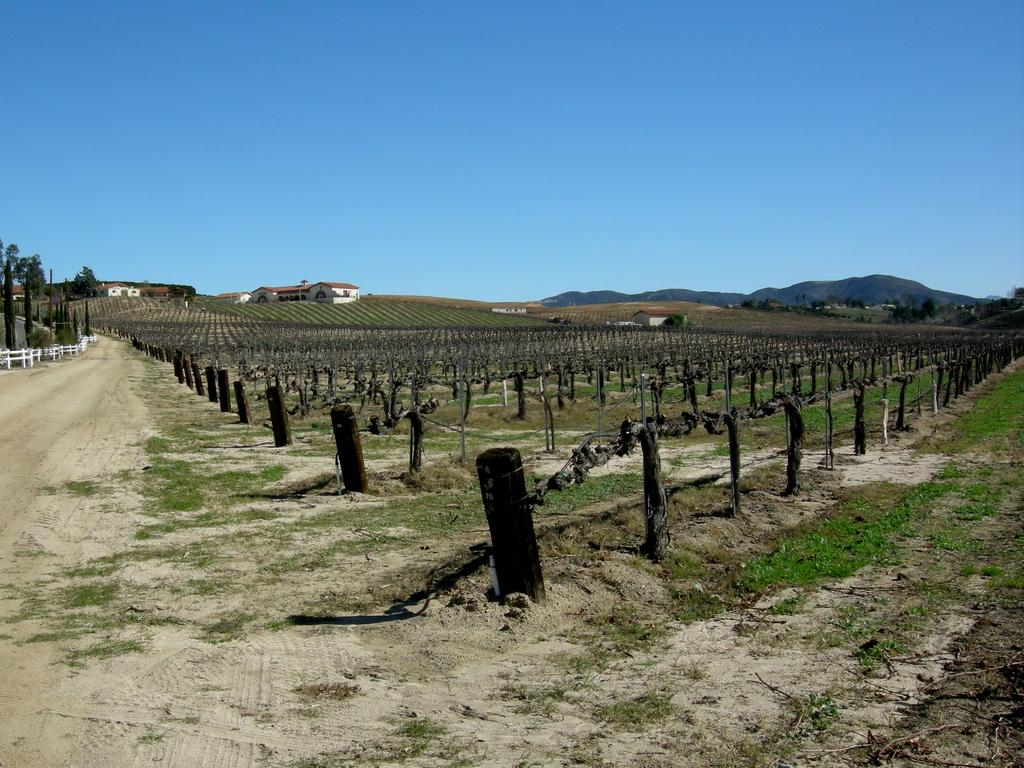What type of landscape is depicted in the image? There is a field in the image. What can be found on the ground in the image? There are objects on the ground in the image. What type of vegetation is present on the ground in the image? Grass is present on the ground in the image. What type of barrier is visible in the image? There is a fence in the image. What type of path is visible in the image? There is a path in the image. What can be seen in the background of the image? Trees, houses, mountains, and the sky are visible in the background of the image. How many mines are visible in the image? There are no mines present in the image. Can you describe the walk depicted in the image? There is no walk depicted in the image; it is a static landscape scene. 